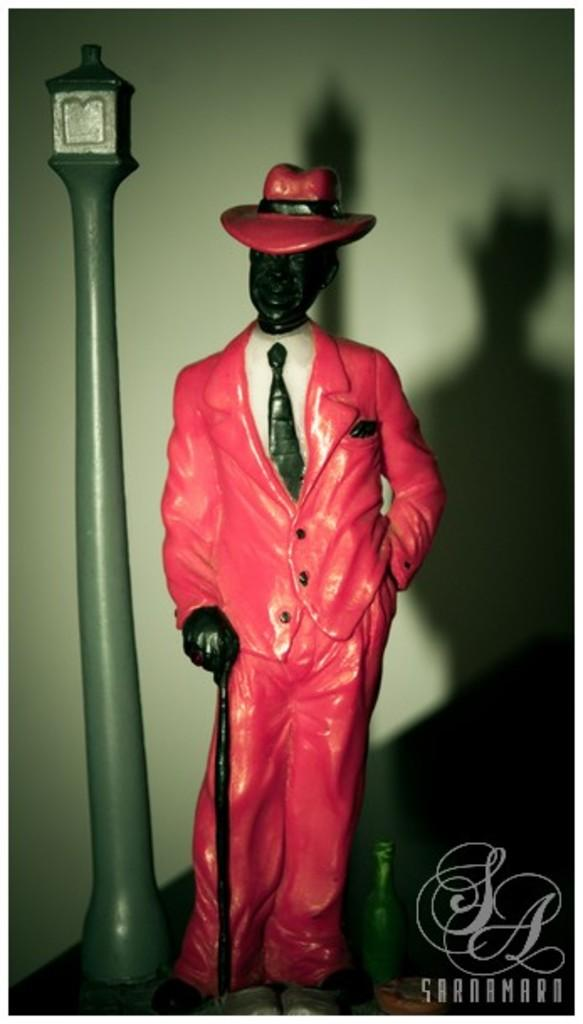What object is present in the image that resembles a toy? There is a toy in the image. What is the toy wearing? The toy is wearing a hat. What is the toy holding? The toy is holding a stick. What other object can be seen in the image? There is a pole in the image. Is there any text or marking in the image? Yes, there is a watermark in the bottom right corner of the image. What type of pie is being served on the plate in the image? There is no plate or pie present in the image; it features a toy wearing a hat and holding a stick, along with a pole and a watermark. 